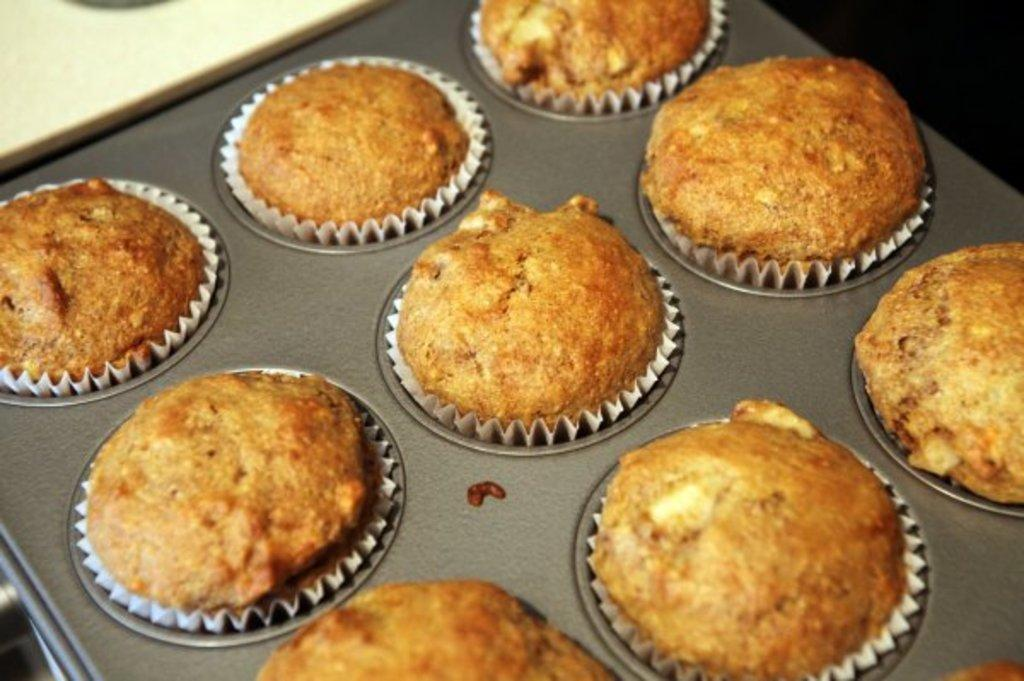What type of food can be seen in the image? There are cupcakes in the image. What is the cupcakes placed on? The cupcakes are placed on an object, but the specific object is not mentioned in the facts provided. What type of paint is being used by the geese in the image? There are no geese or paint present in the image; it only features cupcakes. 